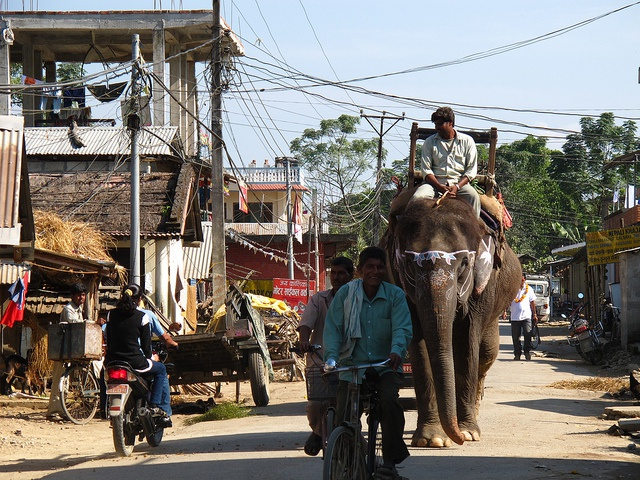Describe the objects in this image and their specific colors. I can see elephant in lightblue, black, maroon, and gray tones, people in lightblue, black, blue, darkblue, and purple tones, people in lightblue, gray, black, ivory, and darkgray tones, bicycle in lightblue, black, gray, darkblue, and blue tones, and people in lightblue, black, navy, white, and gray tones in this image. 